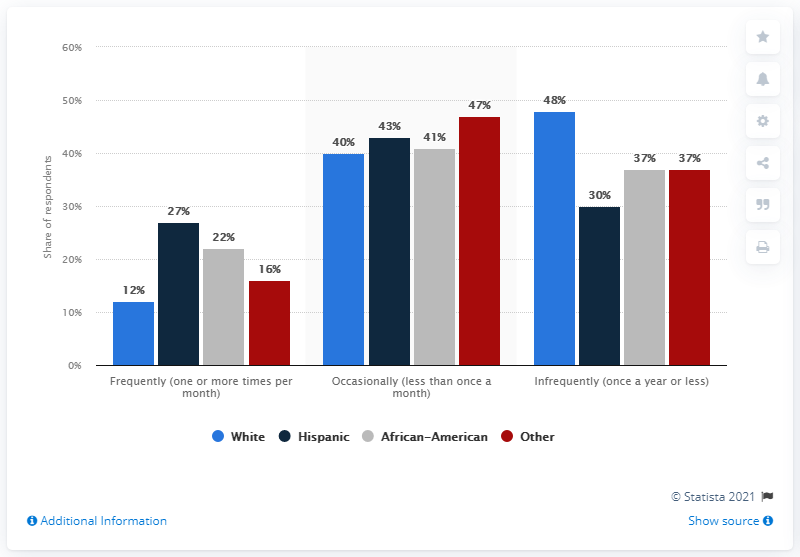Give some essential details in this illustration. According to a recent survey, approximately 12% of white people report going to the movies frequently. The difference in the highest frequency of white people and the lowest frequency of Hispanic people is 21. 